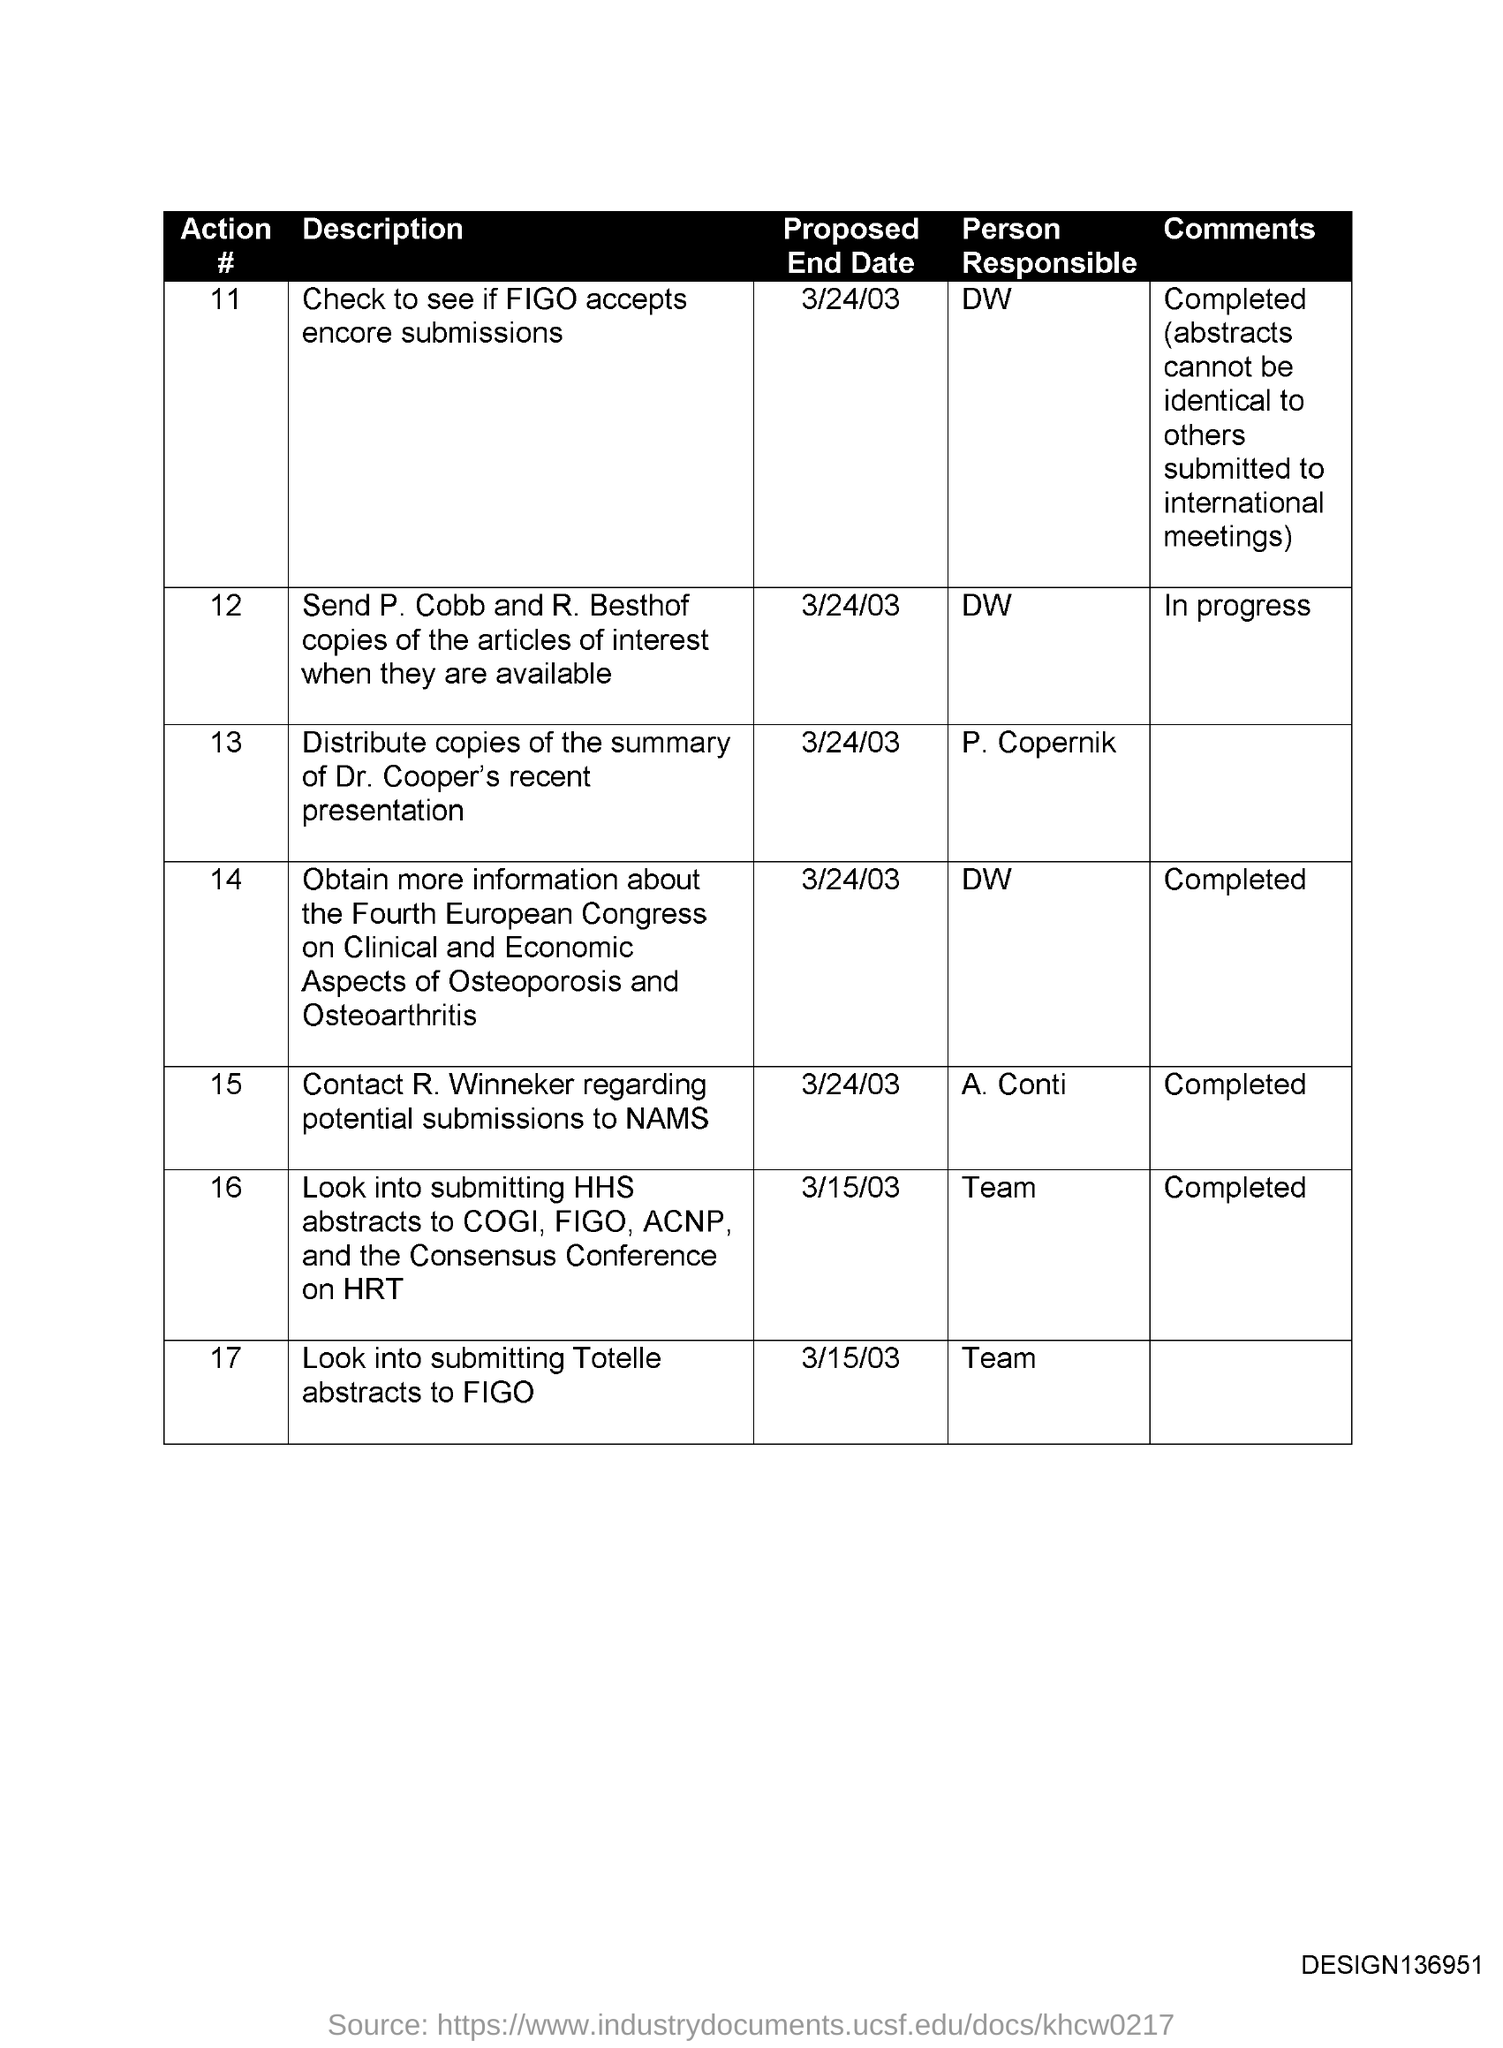Identify some key points in this picture. It is the responsibility of the team to complete action #17. The comment written against Action #14 states that it has been completed. The person responsible for Action #11 is DW. No action has been taken regarding Action #12 due to being in progress. 